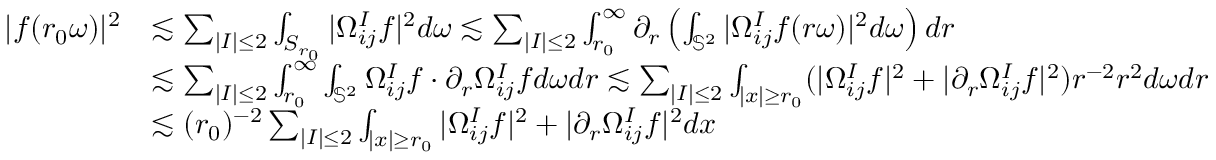<formula> <loc_0><loc_0><loc_500><loc_500>\begin{array} { r l } { | f ( r _ { 0 } \omega ) | ^ { 2 } } & { \lesssim \sum _ { | I | \leq 2 } \int _ { S _ { r _ { 0 } } } | \Omega _ { i j } ^ { I } f | ^ { 2 } d \omega \lesssim \sum _ { | I | \leq 2 } \int _ { r _ { 0 } } ^ { \infty } \partial _ { r } \left ( \int _ { \mathbb { S } ^ { 2 } } | \Omega _ { i j } ^ { I } f ( r \omega ) | ^ { 2 } d \omega \right ) d r } \\ & { \lesssim \sum _ { | I | \leq 2 } \int _ { r _ { 0 } } ^ { \infty } \int _ { \mathbb { S } ^ { 2 } } \Omega _ { i j } ^ { I } f \cdot \partial _ { r } \Omega _ { i j } ^ { I } f d \omega d r \lesssim \sum _ { | I | \leq 2 } \int _ { | x | \geq r _ { 0 } } ( | \Omega _ { i j } ^ { I } f | ^ { 2 } + | \partial _ { r } \Omega _ { i j } ^ { I } f | ^ { 2 } ) r ^ { - 2 } r ^ { 2 } d \omega d r } \\ & { \lesssim ( r _ { 0 } ) ^ { - 2 } \sum _ { | I | \leq 2 } \int _ { | x | \geq r _ { 0 } } | \Omega _ { i j } ^ { I } f | ^ { 2 } + | \partial _ { r } \Omega _ { i j } ^ { I } f | ^ { 2 } d x } \end{array}</formula> 